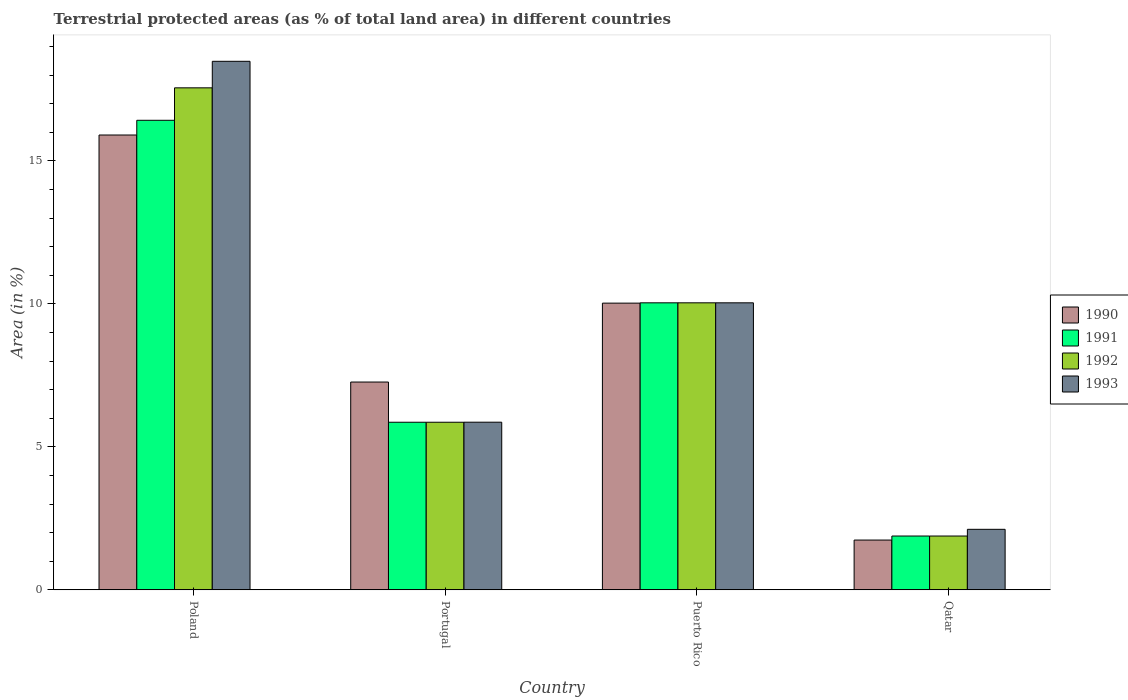How many different coloured bars are there?
Provide a short and direct response. 4. How many groups of bars are there?
Ensure brevity in your answer.  4. Are the number of bars per tick equal to the number of legend labels?
Give a very brief answer. Yes. How many bars are there on the 1st tick from the left?
Your answer should be compact. 4. What is the label of the 4th group of bars from the left?
Offer a very short reply. Qatar. What is the percentage of terrestrial protected land in 1992 in Qatar?
Offer a very short reply. 1.88. Across all countries, what is the maximum percentage of terrestrial protected land in 1991?
Your answer should be compact. 16.42. Across all countries, what is the minimum percentage of terrestrial protected land in 1992?
Offer a terse response. 1.88. In which country was the percentage of terrestrial protected land in 1992 minimum?
Offer a terse response. Qatar. What is the total percentage of terrestrial protected land in 1991 in the graph?
Keep it short and to the point. 34.2. What is the difference between the percentage of terrestrial protected land in 1991 in Portugal and that in Qatar?
Ensure brevity in your answer.  3.98. What is the difference between the percentage of terrestrial protected land in 1993 in Qatar and the percentage of terrestrial protected land in 1991 in Poland?
Make the answer very short. -14.3. What is the average percentage of terrestrial protected land in 1991 per country?
Your answer should be compact. 8.55. In how many countries, is the percentage of terrestrial protected land in 1990 greater than 10 %?
Your answer should be compact. 2. What is the ratio of the percentage of terrestrial protected land in 1990 in Poland to that in Qatar?
Your answer should be very brief. 9.13. Is the percentage of terrestrial protected land in 1992 in Portugal less than that in Qatar?
Your response must be concise. No. What is the difference between the highest and the second highest percentage of terrestrial protected land in 1992?
Make the answer very short. 7.52. What is the difference between the highest and the lowest percentage of terrestrial protected land in 1992?
Offer a very short reply. 15.67. What does the 3rd bar from the left in Puerto Rico represents?
Your response must be concise. 1992. How many bars are there?
Your answer should be compact. 16. Are all the bars in the graph horizontal?
Keep it short and to the point. No. How many legend labels are there?
Your answer should be very brief. 4. How are the legend labels stacked?
Your answer should be compact. Vertical. What is the title of the graph?
Keep it short and to the point. Terrestrial protected areas (as % of total land area) in different countries. Does "2009" appear as one of the legend labels in the graph?
Give a very brief answer. No. What is the label or title of the Y-axis?
Offer a very short reply. Area (in %). What is the Area (in %) of 1990 in Poland?
Give a very brief answer. 15.9. What is the Area (in %) in 1991 in Poland?
Your answer should be very brief. 16.42. What is the Area (in %) of 1992 in Poland?
Your response must be concise. 17.55. What is the Area (in %) in 1993 in Poland?
Your answer should be compact. 18.48. What is the Area (in %) of 1990 in Portugal?
Make the answer very short. 7.27. What is the Area (in %) in 1991 in Portugal?
Give a very brief answer. 5.86. What is the Area (in %) of 1992 in Portugal?
Give a very brief answer. 5.86. What is the Area (in %) in 1993 in Portugal?
Offer a very short reply. 5.86. What is the Area (in %) of 1990 in Puerto Rico?
Provide a short and direct response. 10.03. What is the Area (in %) in 1991 in Puerto Rico?
Offer a terse response. 10.04. What is the Area (in %) in 1992 in Puerto Rico?
Your answer should be compact. 10.04. What is the Area (in %) in 1993 in Puerto Rico?
Your response must be concise. 10.04. What is the Area (in %) in 1990 in Qatar?
Make the answer very short. 1.74. What is the Area (in %) of 1991 in Qatar?
Keep it short and to the point. 1.88. What is the Area (in %) of 1992 in Qatar?
Offer a very short reply. 1.88. What is the Area (in %) in 1993 in Qatar?
Your answer should be compact. 2.12. Across all countries, what is the maximum Area (in %) of 1990?
Keep it short and to the point. 15.9. Across all countries, what is the maximum Area (in %) of 1991?
Make the answer very short. 16.42. Across all countries, what is the maximum Area (in %) in 1992?
Give a very brief answer. 17.55. Across all countries, what is the maximum Area (in %) in 1993?
Provide a succinct answer. 18.48. Across all countries, what is the minimum Area (in %) in 1990?
Provide a short and direct response. 1.74. Across all countries, what is the minimum Area (in %) of 1991?
Ensure brevity in your answer.  1.88. Across all countries, what is the minimum Area (in %) in 1992?
Provide a short and direct response. 1.88. Across all countries, what is the minimum Area (in %) of 1993?
Keep it short and to the point. 2.12. What is the total Area (in %) in 1990 in the graph?
Ensure brevity in your answer.  34.94. What is the total Area (in %) of 1991 in the graph?
Ensure brevity in your answer.  34.2. What is the total Area (in %) of 1992 in the graph?
Ensure brevity in your answer.  35.33. What is the total Area (in %) of 1993 in the graph?
Give a very brief answer. 36.5. What is the difference between the Area (in %) of 1990 in Poland and that in Portugal?
Ensure brevity in your answer.  8.64. What is the difference between the Area (in %) of 1991 in Poland and that in Portugal?
Your response must be concise. 10.56. What is the difference between the Area (in %) in 1992 in Poland and that in Portugal?
Provide a succinct answer. 11.69. What is the difference between the Area (in %) in 1993 in Poland and that in Portugal?
Give a very brief answer. 12.62. What is the difference between the Area (in %) in 1990 in Poland and that in Puerto Rico?
Offer a very short reply. 5.88. What is the difference between the Area (in %) of 1991 in Poland and that in Puerto Rico?
Provide a succinct answer. 6.38. What is the difference between the Area (in %) of 1992 in Poland and that in Puerto Rico?
Your response must be concise. 7.52. What is the difference between the Area (in %) of 1993 in Poland and that in Puerto Rico?
Offer a very short reply. 8.45. What is the difference between the Area (in %) in 1990 in Poland and that in Qatar?
Provide a succinct answer. 14.16. What is the difference between the Area (in %) of 1991 in Poland and that in Qatar?
Your answer should be compact. 14.54. What is the difference between the Area (in %) of 1992 in Poland and that in Qatar?
Provide a succinct answer. 15.67. What is the difference between the Area (in %) in 1993 in Poland and that in Qatar?
Offer a very short reply. 16.37. What is the difference between the Area (in %) in 1990 in Portugal and that in Puerto Rico?
Your answer should be very brief. -2.76. What is the difference between the Area (in %) of 1991 in Portugal and that in Puerto Rico?
Offer a very short reply. -4.18. What is the difference between the Area (in %) of 1992 in Portugal and that in Puerto Rico?
Offer a very short reply. -4.18. What is the difference between the Area (in %) in 1993 in Portugal and that in Puerto Rico?
Your response must be concise. -4.17. What is the difference between the Area (in %) in 1990 in Portugal and that in Qatar?
Offer a very short reply. 5.53. What is the difference between the Area (in %) in 1991 in Portugal and that in Qatar?
Provide a short and direct response. 3.98. What is the difference between the Area (in %) in 1992 in Portugal and that in Qatar?
Make the answer very short. 3.98. What is the difference between the Area (in %) of 1993 in Portugal and that in Qatar?
Keep it short and to the point. 3.75. What is the difference between the Area (in %) of 1990 in Puerto Rico and that in Qatar?
Ensure brevity in your answer.  8.28. What is the difference between the Area (in %) of 1991 in Puerto Rico and that in Qatar?
Provide a succinct answer. 8.15. What is the difference between the Area (in %) in 1992 in Puerto Rico and that in Qatar?
Make the answer very short. 8.15. What is the difference between the Area (in %) in 1993 in Puerto Rico and that in Qatar?
Keep it short and to the point. 7.92. What is the difference between the Area (in %) of 1990 in Poland and the Area (in %) of 1991 in Portugal?
Keep it short and to the point. 10.04. What is the difference between the Area (in %) in 1990 in Poland and the Area (in %) in 1992 in Portugal?
Offer a very short reply. 10.04. What is the difference between the Area (in %) of 1990 in Poland and the Area (in %) of 1993 in Portugal?
Your response must be concise. 10.04. What is the difference between the Area (in %) in 1991 in Poland and the Area (in %) in 1992 in Portugal?
Make the answer very short. 10.56. What is the difference between the Area (in %) in 1991 in Poland and the Area (in %) in 1993 in Portugal?
Offer a terse response. 10.56. What is the difference between the Area (in %) in 1992 in Poland and the Area (in %) in 1993 in Portugal?
Provide a short and direct response. 11.69. What is the difference between the Area (in %) in 1990 in Poland and the Area (in %) in 1991 in Puerto Rico?
Provide a succinct answer. 5.87. What is the difference between the Area (in %) in 1990 in Poland and the Area (in %) in 1992 in Puerto Rico?
Make the answer very short. 5.87. What is the difference between the Area (in %) of 1990 in Poland and the Area (in %) of 1993 in Puerto Rico?
Keep it short and to the point. 5.87. What is the difference between the Area (in %) in 1991 in Poland and the Area (in %) in 1992 in Puerto Rico?
Make the answer very short. 6.38. What is the difference between the Area (in %) in 1991 in Poland and the Area (in %) in 1993 in Puerto Rico?
Ensure brevity in your answer.  6.38. What is the difference between the Area (in %) in 1992 in Poland and the Area (in %) in 1993 in Puerto Rico?
Make the answer very short. 7.52. What is the difference between the Area (in %) in 1990 in Poland and the Area (in %) in 1991 in Qatar?
Offer a very short reply. 14.02. What is the difference between the Area (in %) in 1990 in Poland and the Area (in %) in 1992 in Qatar?
Provide a succinct answer. 14.02. What is the difference between the Area (in %) in 1990 in Poland and the Area (in %) in 1993 in Qatar?
Offer a very short reply. 13.79. What is the difference between the Area (in %) of 1991 in Poland and the Area (in %) of 1992 in Qatar?
Offer a terse response. 14.54. What is the difference between the Area (in %) in 1991 in Poland and the Area (in %) in 1993 in Qatar?
Your response must be concise. 14.3. What is the difference between the Area (in %) in 1992 in Poland and the Area (in %) in 1993 in Qatar?
Your answer should be very brief. 15.44. What is the difference between the Area (in %) in 1990 in Portugal and the Area (in %) in 1991 in Puerto Rico?
Provide a short and direct response. -2.77. What is the difference between the Area (in %) of 1990 in Portugal and the Area (in %) of 1992 in Puerto Rico?
Offer a very short reply. -2.77. What is the difference between the Area (in %) of 1990 in Portugal and the Area (in %) of 1993 in Puerto Rico?
Your answer should be compact. -2.77. What is the difference between the Area (in %) of 1991 in Portugal and the Area (in %) of 1992 in Puerto Rico?
Offer a terse response. -4.18. What is the difference between the Area (in %) in 1991 in Portugal and the Area (in %) in 1993 in Puerto Rico?
Keep it short and to the point. -4.18. What is the difference between the Area (in %) of 1992 in Portugal and the Area (in %) of 1993 in Puerto Rico?
Keep it short and to the point. -4.18. What is the difference between the Area (in %) of 1990 in Portugal and the Area (in %) of 1991 in Qatar?
Keep it short and to the point. 5.38. What is the difference between the Area (in %) of 1990 in Portugal and the Area (in %) of 1992 in Qatar?
Ensure brevity in your answer.  5.38. What is the difference between the Area (in %) in 1990 in Portugal and the Area (in %) in 1993 in Qatar?
Offer a very short reply. 5.15. What is the difference between the Area (in %) of 1991 in Portugal and the Area (in %) of 1992 in Qatar?
Offer a terse response. 3.98. What is the difference between the Area (in %) of 1991 in Portugal and the Area (in %) of 1993 in Qatar?
Your answer should be compact. 3.74. What is the difference between the Area (in %) of 1992 in Portugal and the Area (in %) of 1993 in Qatar?
Ensure brevity in your answer.  3.74. What is the difference between the Area (in %) in 1990 in Puerto Rico and the Area (in %) in 1991 in Qatar?
Ensure brevity in your answer.  8.14. What is the difference between the Area (in %) of 1990 in Puerto Rico and the Area (in %) of 1992 in Qatar?
Give a very brief answer. 8.14. What is the difference between the Area (in %) of 1990 in Puerto Rico and the Area (in %) of 1993 in Qatar?
Your answer should be compact. 7.91. What is the difference between the Area (in %) in 1991 in Puerto Rico and the Area (in %) in 1992 in Qatar?
Ensure brevity in your answer.  8.15. What is the difference between the Area (in %) of 1991 in Puerto Rico and the Area (in %) of 1993 in Qatar?
Offer a terse response. 7.92. What is the difference between the Area (in %) of 1992 in Puerto Rico and the Area (in %) of 1993 in Qatar?
Provide a succinct answer. 7.92. What is the average Area (in %) in 1990 per country?
Provide a succinct answer. 8.73. What is the average Area (in %) in 1991 per country?
Ensure brevity in your answer.  8.55. What is the average Area (in %) in 1992 per country?
Your response must be concise. 8.83. What is the average Area (in %) in 1993 per country?
Make the answer very short. 9.12. What is the difference between the Area (in %) in 1990 and Area (in %) in 1991 in Poland?
Make the answer very short. -0.51. What is the difference between the Area (in %) in 1990 and Area (in %) in 1992 in Poland?
Your answer should be compact. -1.65. What is the difference between the Area (in %) in 1990 and Area (in %) in 1993 in Poland?
Keep it short and to the point. -2.58. What is the difference between the Area (in %) of 1991 and Area (in %) of 1992 in Poland?
Offer a very short reply. -1.13. What is the difference between the Area (in %) in 1991 and Area (in %) in 1993 in Poland?
Offer a terse response. -2.06. What is the difference between the Area (in %) of 1992 and Area (in %) of 1993 in Poland?
Your answer should be compact. -0.93. What is the difference between the Area (in %) in 1990 and Area (in %) in 1991 in Portugal?
Your answer should be compact. 1.41. What is the difference between the Area (in %) in 1990 and Area (in %) in 1992 in Portugal?
Ensure brevity in your answer.  1.41. What is the difference between the Area (in %) of 1990 and Area (in %) of 1993 in Portugal?
Give a very brief answer. 1.4. What is the difference between the Area (in %) of 1991 and Area (in %) of 1993 in Portugal?
Your answer should be compact. -0. What is the difference between the Area (in %) in 1992 and Area (in %) in 1993 in Portugal?
Make the answer very short. -0. What is the difference between the Area (in %) in 1990 and Area (in %) in 1991 in Puerto Rico?
Provide a short and direct response. -0.01. What is the difference between the Area (in %) of 1990 and Area (in %) of 1992 in Puerto Rico?
Keep it short and to the point. -0.01. What is the difference between the Area (in %) of 1990 and Area (in %) of 1993 in Puerto Rico?
Provide a succinct answer. -0.01. What is the difference between the Area (in %) of 1991 and Area (in %) of 1993 in Puerto Rico?
Provide a succinct answer. 0. What is the difference between the Area (in %) of 1992 and Area (in %) of 1993 in Puerto Rico?
Make the answer very short. 0. What is the difference between the Area (in %) of 1990 and Area (in %) of 1991 in Qatar?
Keep it short and to the point. -0.14. What is the difference between the Area (in %) in 1990 and Area (in %) in 1992 in Qatar?
Provide a short and direct response. -0.14. What is the difference between the Area (in %) of 1990 and Area (in %) of 1993 in Qatar?
Your response must be concise. -0.38. What is the difference between the Area (in %) of 1991 and Area (in %) of 1993 in Qatar?
Offer a terse response. -0.23. What is the difference between the Area (in %) of 1992 and Area (in %) of 1993 in Qatar?
Keep it short and to the point. -0.23. What is the ratio of the Area (in %) of 1990 in Poland to that in Portugal?
Your answer should be compact. 2.19. What is the ratio of the Area (in %) of 1991 in Poland to that in Portugal?
Make the answer very short. 2.8. What is the ratio of the Area (in %) of 1992 in Poland to that in Portugal?
Your answer should be very brief. 3. What is the ratio of the Area (in %) of 1993 in Poland to that in Portugal?
Give a very brief answer. 3.15. What is the ratio of the Area (in %) of 1990 in Poland to that in Puerto Rico?
Make the answer very short. 1.59. What is the ratio of the Area (in %) in 1991 in Poland to that in Puerto Rico?
Offer a terse response. 1.64. What is the ratio of the Area (in %) in 1992 in Poland to that in Puerto Rico?
Your answer should be very brief. 1.75. What is the ratio of the Area (in %) of 1993 in Poland to that in Puerto Rico?
Keep it short and to the point. 1.84. What is the ratio of the Area (in %) in 1990 in Poland to that in Qatar?
Your answer should be compact. 9.13. What is the ratio of the Area (in %) of 1991 in Poland to that in Qatar?
Make the answer very short. 8.72. What is the ratio of the Area (in %) of 1992 in Poland to that in Qatar?
Keep it short and to the point. 9.33. What is the ratio of the Area (in %) in 1993 in Poland to that in Qatar?
Your response must be concise. 8.73. What is the ratio of the Area (in %) of 1990 in Portugal to that in Puerto Rico?
Your answer should be compact. 0.72. What is the ratio of the Area (in %) of 1991 in Portugal to that in Puerto Rico?
Ensure brevity in your answer.  0.58. What is the ratio of the Area (in %) of 1992 in Portugal to that in Puerto Rico?
Give a very brief answer. 0.58. What is the ratio of the Area (in %) of 1993 in Portugal to that in Puerto Rico?
Ensure brevity in your answer.  0.58. What is the ratio of the Area (in %) of 1990 in Portugal to that in Qatar?
Your response must be concise. 4.17. What is the ratio of the Area (in %) in 1991 in Portugal to that in Qatar?
Your answer should be very brief. 3.11. What is the ratio of the Area (in %) in 1992 in Portugal to that in Qatar?
Your answer should be very brief. 3.11. What is the ratio of the Area (in %) in 1993 in Portugal to that in Qatar?
Make the answer very short. 2.77. What is the ratio of the Area (in %) in 1990 in Puerto Rico to that in Qatar?
Your answer should be very brief. 5.76. What is the ratio of the Area (in %) in 1991 in Puerto Rico to that in Qatar?
Your response must be concise. 5.33. What is the ratio of the Area (in %) in 1992 in Puerto Rico to that in Qatar?
Offer a terse response. 5.33. What is the ratio of the Area (in %) of 1993 in Puerto Rico to that in Qatar?
Provide a succinct answer. 4.74. What is the difference between the highest and the second highest Area (in %) in 1990?
Offer a terse response. 5.88. What is the difference between the highest and the second highest Area (in %) in 1991?
Provide a succinct answer. 6.38. What is the difference between the highest and the second highest Area (in %) in 1992?
Keep it short and to the point. 7.52. What is the difference between the highest and the second highest Area (in %) in 1993?
Provide a short and direct response. 8.45. What is the difference between the highest and the lowest Area (in %) in 1990?
Offer a terse response. 14.16. What is the difference between the highest and the lowest Area (in %) of 1991?
Provide a short and direct response. 14.54. What is the difference between the highest and the lowest Area (in %) of 1992?
Your answer should be very brief. 15.67. What is the difference between the highest and the lowest Area (in %) of 1993?
Offer a terse response. 16.37. 